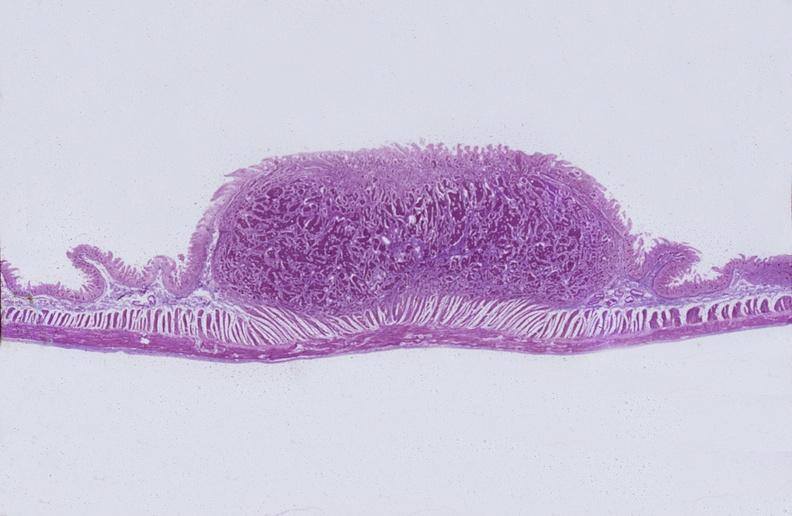does this image show intestine, carcinoid tumor?
Answer the question using a single word or phrase. Yes 